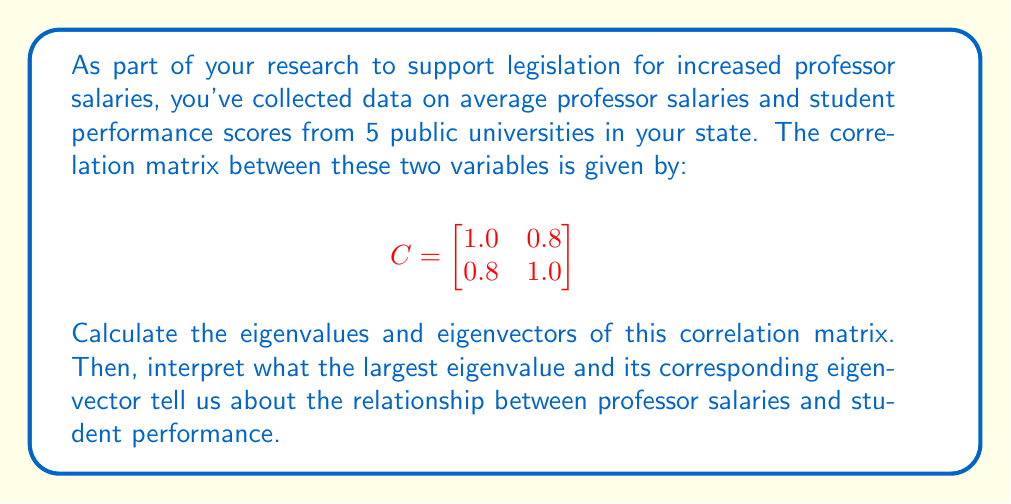Provide a solution to this math problem. To solve this problem, we'll follow these steps:

1) Find the eigenvalues of the correlation matrix.
2) Find the eigenvectors corresponding to each eigenvalue.
3) Interpret the results.

Step 1: Finding the eigenvalues

To find the eigenvalues, we solve the characteristic equation:
$$\det(C - \lambda I) = 0$$

$$\begin{vmatrix}
1-\lambda & 0.8 \\
0.8 & 1-\lambda
\end{vmatrix} = 0$$

$$(1-\lambda)^2 - 0.64 = 0$$
$$\lambda^2 - 2\lambda + 0.36 = 0$$

Solving this quadratic equation:
$$\lambda_1 = 1.8, \lambda_2 = 0.2$$

Step 2: Finding the eigenvectors

For $\lambda_1 = 1.8$:
$$(C - 1.8I)\vec{v_1} = \vec{0}$$

$$\begin{bmatrix}
-0.8 & 0.8 \\
0.8 & -0.8
\end{bmatrix}\begin{bmatrix}
v_1 \\
v_2
\end{bmatrix} = \begin{bmatrix}
0 \\
0
\end{bmatrix}$$

This gives us $v_1 = v_2$. Normalizing, we get:
$$\vec{v_1} = \frac{1}{\sqrt{2}}\begin{bmatrix}
1 \\
1
\end{bmatrix}$$

For $\lambda_2 = 0.2$, we similarly find:
$$\vec{v_2} = \frac{1}{\sqrt{2}}\begin{bmatrix}
1 \\
-1
\end{bmatrix}$$

Step 3: Interpretation

The largest eigenvalue is 1.8, which explains 90% of the total variance (1.8 / (1.8 + 0.2) = 0.9). Its corresponding eigenvector $\vec{v_1}$ has equal positive components, indicating a strong positive correlation between professor salaries and student performance.

This suggests that as professor salaries increase, student performance tends to increase as well, supporting the argument for allocating more funding to increase professor salaries.
Answer: Eigenvalues: $\lambda_1 = 1.8$, $\lambda_2 = 0.2$

Eigenvectors: $\vec{v_1} = \frac{1}{\sqrt{2}}\begin{bmatrix}
1 \\
1
\end{bmatrix}$, $\vec{v_2} = \frac{1}{\sqrt{2}}\begin{bmatrix}
1 \\
-1
\end{bmatrix}$

Interpretation: The largest eigenvalue (1.8) and its corresponding eigenvector indicate a strong positive correlation between professor salaries and student performance, supporting the argument for increased funding for professor salaries. 